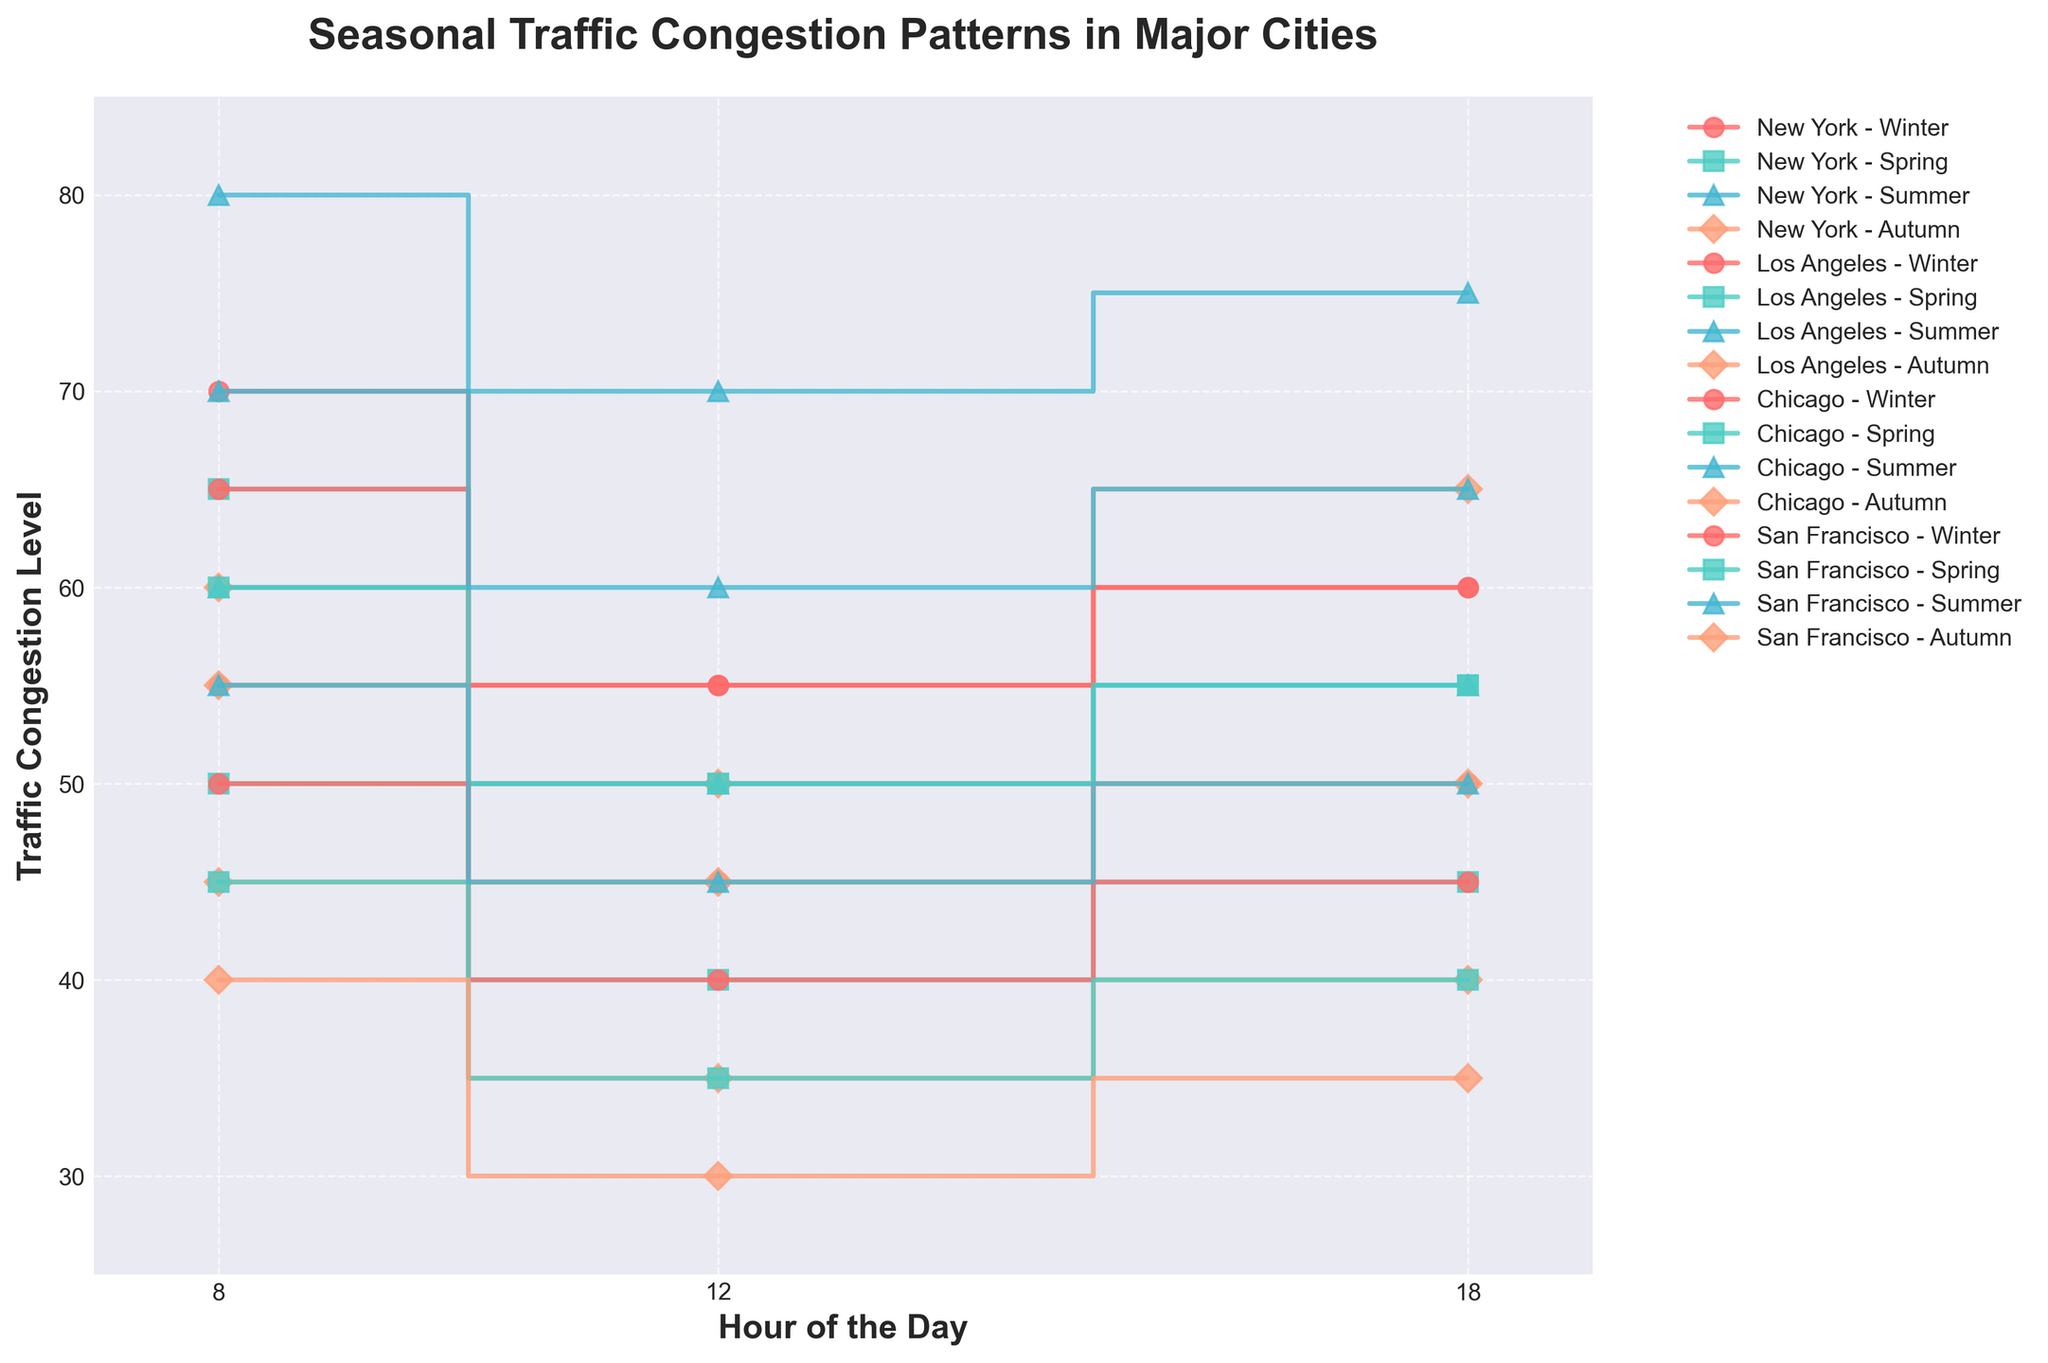What's the title of the plot? The title of the plot is specified at the top of the figure, which is usually in a larger or bold font to make it distinguishable.
Answer: Seasonal Traffic Congestion Patterns in Major Cities What's the traffic congestion level for New York during the summer at 8 am? Locate the line labeled "New York - Summer" and find the corresponding value for 8 am on the x-axis. The congestion level is at the height of the point marked on this line.
Answer: 80 Does any city have a traffic congestion level below 40 at any hour? Look at all the lines in the plot to check if there are any points that fall below the value of 40 on the y-axis. Los Angeles in Autumn and San Francisco in Autumn both have congestion levels below 40 at certain hours.
Answer: Yes Which season has the highest traffic congestion level in New York at 12 pm? Compare the values of the lines labeled with different seasons (Winter, Spring, Summer, Autumn) for New York at the 12 pm mark on the x-axis. The highest point will determine the answer.
Answer: Summer What is the difference in traffic congestion levels between Winter and Autumn at 8 am in Chicago? Locate the lines labeled "Chicago - Winter" and "Chicago - Autumn". Find the points for 8 am and calculate the difference by subtracting the Autumn value from the Winter value. Winter is at 65 and Autumn is at 55.
Answer: 10 Which city has the least variability in traffic congestion levels across different seasons at 18 pm? For each city, find the lines and their corresponding points at 18 pm and observe the variability, defined by how much the points differ from each other. San Francisco at 18 pm shows less variation with values 35 in Autumn, 40 in Spring, 45 in Winter, and 50 in Summer.
Answer: San Francisco How does traffic congestion change from 8 am to 12 pm in Los Angeles in Summer? Follow the line labeled "Los Angeles - Summer" from the point at 8 am to the point at 12 pm. Observe whether the line goes up, down, or remains the same. It decreases from 60 to 50.
Answer: Decreases What hours show the highest traffic congestion in San Francisco across all seasons? Examine the points for San Francisco and identify the hours (8, 12, or 18) that generally show the highest values across all the seasonal lines. 8 am shows the highest values across all seasons.
Answer: 8 am 